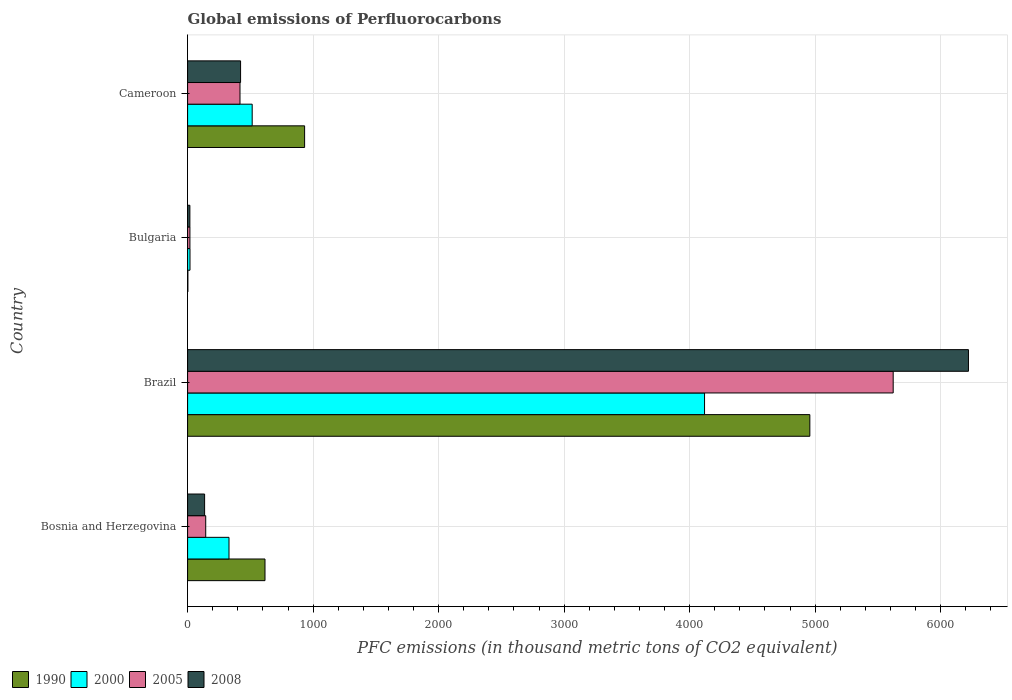Are the number of bars per tick equal to the number of legend labels?
Your answer should be very brief. Yes. How many bars are there on the 2nd tick from the bottom?
Offer a terse response. 4. What is the label of the 4th group of bars from the top?
Give a very brief answer. Bosnia and Herzegovina. What is the global emissions of Perfluorocarbons in 2005 in Bulgaria?
Your answer should be compact. 18.5. Across all countries, what is the maximum global emissions of Perfluorocarbons in 2008?
Give a very brief answer. 6221.8. Across all countries, what is the minimum global emissions of Perfluorocarbons in 1990?
Offer a very short reply. 2.2. In which country was the global emissions of Perfluorocarbons in 2008 maximum?
Make the answer very short. Brazil. In which country was the global emissions of Perfluorocarbons in 1990 minimum?
Ensure brevity in your answer.  Bulgaria. What is the total global emissions of Perfluorocarbons in 2008 in the graph?
Your answer should be compact. 6797.7. What is the difference between the global emissions of Perfluorocarbons in 1990 in Bosnia and Herzegovina and that in Cameroon?
Your response must be concise. -315.6. What is the difference between the global emissions of Perfluorocarbons in 1990 in Brazil and the global emissions of Perfluorocarbons in 2005 in Bosnia and Herzegovina?
Your answer should be compact. 4813.7. What is the average global emissions of Perfluorocarbons in 2005 per country?
Make the answer very short. 1550.62. What is the difference between the global emissions of Perfluorocarbons in 1990 and global emissions of Perfluorocarbons in 2008 in Bulgaria?
Ensure brevity in your answer.  -16. In how many countries, is the global emissions of Perfluorocarbons in 1990 greater than 3400 thousand metric tons?
Offer a very short reply. 1. What is the ratio of the global emissions of Perfluorocarbons in 1990 in Bulgaria to that in Cameroon?
Provide a succinct answer. 0. What is the difference between the highest and the second highest global emissions of Perfluorocarbons in 2008?
Provide a short and direct response. 5799.7. What is the difference between the highest and the lowest global emissions of Perfluorocarbons in 2000?
Offer a very short reply. 4100. Is it the case that in every country, the sum of the global emissions of Perfluorocarbons in 1990 and global emissions of Perfluorocarbons in 2000 is greater than the sum of global emissions of Perfluorocarbons in 2008 and global emissions of Perfluorocarbons in 2005?
Offer a very short reply. No. What does the 4th bar from the top in Bulgaria represents?
Your answer should be compact. 1990. What does the 4th bar from the bottom in Bulgaria represents?
Ensure brevity in your answer.  2008. Is it the case that in every country, the sum of the global emissions of Perfluorocarbons in 2005 and global emissions of Perfluorocarbons in 2008 is greater than the global emissions of Perfluorocarbons in 2000?
Offer a very short reply. No. How many bars are there?
Provide a succinct answer. 16. Are all the bars in the graph horizontal?
Make the answer very short. Yes. How many countries are there in the graph?
Make the answer very short. 4. What is the difference between two consecutive major ticks on the X-axis?
Provide a succinct answer. 1000. Does the graph contain any zero values?
Your response must be concise. No. What is the title of the graph?
Keep it short and to the point. Global emissions of Perfluorocarbons. What is the label or title of the X-axis?
Give a very brief answer. PFC emissions (in thousand metric tons of CO2 equivalent). What is the label or title of the Y-axis?
Provide a short and direct response. Country. What is the PFC emissions (in thousand metric tons of CO2 equivalent) of 1990 in Bosnia and Herzegovina?
Offer a terse response. 616.7. What is the PFC emissions (in thousand metric tons of CO2 equivalent) in 2000 in Bosnia and Herzegovina?
Your answer should be very brief. 329.9. What is the PFC emissions (in thousand metric tons of CO2 equivalent) in 2005 in Bosnia and Herzegovina?
Your answer should be compact. 144.4. What is the PFC emissions (in thousand metric tons of CO2 equivalent) of 2008 in Bosnia and Herzegovina?
Offer a terse response. 135.6. What is the PFC emissions (in thousand metric tons of CO2 equivalent) of 1990 in Brazil?
Your response must be concise. 4958.1. What is the PFC emissions (in thousand metric tons of CO2 equivalent) in 2000 in Brazil?
Keep it short and to the point. 4119.1. What is the PFC emissions (in thousand metric tons of CO2 equivalent) in 2005 in Brazil?
Ensure brevity in your answer.  5622.1. What is the PFC emissions (in thousand metric tons of CO2 equivalent) of 2008 in Brazil?
Make the answer very short. 6221.8. What is the PFC emissions (in thousand metric tons of CO2 equivalent) in 2000 in Bulgaria?
Keep it short and to the point. 19.1. What is the PFC emissions (in thousand metric tons of CO2 equivalent) in 2005 in Bulgaria?
Your answer should be compact. 18.5. What is the PFC emissions (in thousand metric tons of CO2 equivalent) in 2008 in Bulgaria?
Provide a succinct answer. 18.2. What is the PFC emissions (in thousand metric tons of CO2 equivalent) in 1990 in Cameroon?
Offer a terse response. 932.3. What is the PFC emissions (in thousand metric tons of CO2 equivalent) of 2000 in Cameroon?
Keep it short and to the point. 514.7. What is the PFC emissions (in thousand metric tons of CO2 equivalent) of 2005 in Cameroon?
Make the answer very short. 417.5. What is the PFC emissions (in thousand metric tons of CO2 equivalent) of 2008 in Cameroon?
Your answer should be very brief. 422.1. Across all countries, what is the maximum PFC emissions (in thousand metric tons of CO2 equivalent) in 1990?
Make the answer very short. 4958.1. Across all countries, what is the maximum PFC emissions (in thousand metric tons of CO2 equivalent) of 2000?
Ensure brevity in your answer.  4119.1. Across all countries, what is the maximum PFC emissions (in thousand metric tons of CO2 equivalent) in 2005?
Keep it short and to the point. 5622.1. Across all countries, what is the maximum PFC emissions (in thousand metric tons of CO2 equivalent) in 2008?
Your response must be concise. 6221.8. Across all countries, what is the minimum PFC emissions (in thousand metric tons of CO2 equivalent) of 1990?
Keep it short and to the point. 2.2. Across all countries, what is the minimum PFC emissions (in thousand metric tons of CO2 equivalent) of 2005?
Provide a succinct answer. 18.5. Across all countries, what is the minimum PFC emissions (in thousand metric tons of CO2 equivalent) in 2008?
Ensure brevity in your answer.  18.2. What is the total PFC emissions (in thousand metric tons of CO2 equivalent) in 1990 in the graph?
Keep it short and to the point. 6509.3. What is the total PFC emissions (in thousand metric tons of CO2 equivalent) in 2000 in the graph?
Ensure brevity in your answer.  4982.8. What is the total PFC emissions (in thousand metric tons of CO2 equivalent) of 2005 in the graph?
Ensure brevity in your answer.  6202.5. What is the total PFC emissions (in thousand metric tons of CO2 equivalent) of 2008 in the graph?
Your answer should be compact. 6797.7. What is the difference between the PFC emissions (in thousand metric tons of CO2 equivalent) in 1990 in Bosnia and Herzegovina and that in Brazil?
Keep it short and to the point. -4341.4. What is the difference between the PFC emissions (in thousand metric tons of CO2 equivalent) in 2000 in Bosnia and Herzegovina and that in Brazil?
Your answer should be compact. -3789.2. What is the difference between the PFC emissions (in thousand metric tons of CO2 equivalent) of 2005 in Bosnia and Herzegovina and that in Brazil?
Provide a short and direct response. -5477.7. What is the difference between the PFC emissions (in thousand metric tons of CO2 equivalent) in 2008 in Bosnia and Herzegovina and that in Brazil?
Your answer should be compact. -6086.2. What is the difference between the PFC emissions (in thousand metric tons of CO2 equivalent) of 1990 in Bosnia and Herzegovina and that in Bulgaria?
Your answer should be very brief. 614.5. What is the difference between the PFC emissions (in thousand metric tons of CO2 equivalent) of 2000 in Bosnia and Herzegovina and that in Bulgaria?
Keep it short and to the point. 310.8. What is the difference between the PFC emissions (in thousand metric tons of CO2 equivalent) in 2005 in Bosnia and Herzegovina and that in Bulgaria?
Offer a very short reply. 125.9. What is the difference between the PFC emissions (in thousand metric tons of CO2 equivalent) of 2008 in Bosnia and Herzegovina and that in Bulgaria?
Offer a very short reply. 117.4. What is the difference between the PFC emissions (in thousand metric tons of CO2 equivalent) of 1990 in Bosnia and Herzegovina and that in Cameroon?
Make the answer very short. -315.6. What is the difference between the PFC emissions (in thousand metric tons of CO2 equivalent) in 2000 in Bosnia and Herzegovina and that in Cameroon?
Make the answer very short. -184.8. What is the difference between the PFC emissions (in thousand metric tons of CO2 equivalent) of 2005 in Bosnia and Herzegovina and that in Cameroon?
Your answer should be compact. -273.1. What is the difference between the PFC emissions (in thousand metric tons of CO2 equivalent) of 2008 in Bosnia and Herzegovina and that in Cameroon?
Offer a very short reply. -286.5. What is the difference between the PFC emissions (in thousand metric tons of CO2 equivalent) in 1990 in Brazil and that in Bulgaria?
Your answer should be compact. 4955.9. What is the difference between the PFC emissions (in thousand metric tons of CO2 equivalent) in 2000 in Brazil and that in Bulgaria?
Your response must be concise. 4100. What is the difference between the PFC emissions (in thousand metric tons of CO2 equivalent) of 2005 in Brazil and that in Bulgaria?
Ensure brevity in your answer.  5603.6. What is the difference between the PFC emissions (in thousand metric tons of CO2 equivalent) of 2008 in Brazil and that in Bulgaria?
Ensure brevity in your answer.  6203.6. What is the difference between the PFC emissions (in thousand metric tons of CO2 equivalent) in 1990 in Brazil and that in Cameroon?
Your response must be concise. 4025.8. What is the difference between the PFC emissions (in thousand metric tons of CO2 equivalent) in 2000 in Brazil and that in Cameroon?
Give a very brief answer. 3604.4. What is the difference between the PFC emissions (in thousand metric tons of CO2 equivalent) of 2005 in Brazil and that in Cameroon?
Make the answer very short. 5204.6. What is the difference between the PFC emissions (in thousand metric tons of CO2 equivalent) in 2008 in Brazil and that in Cameroon?
Your answer should be compact. 5799.7. What is the difference between the PFC emissions (in thousand metric tons of CO2 equivalent) in 1990 in Bulgaria and that in Cameroon?
Make the answer very short. -930.1. What is the difference between the PFC emissions (in thousand metric tons of CO2 equivalent) of 2000 in Bulgaria and that in Cameroon?
Give a very brief answer. -495.6. What is the difference between the PFC emissions (in thousand metric tons of CO2 equivalent) of 2005 in Bulgaria and that in Cameroon?
Provide a succinct answer. -399. What is the difference between the PFC emissions (in thousand metric tons of CO2 equivalent) in 2008 in Bulgaria and that in Cameroon?
Give a very brief answer. -403.9. What is the difference between the PFC emissions (in thousand metric tons of CO2 equivalent) in 1990 in Bosnia and Herzegovina and the PFC emissions (in thousand metric tons of CO2 equivalent) in 2000 in Brazil?
Provide a succinct answer. -3502.4. What is the difference between the PFC emissions (in thousand metric tons of CO2 equivalent) of 1990 in Bosnia and Herzegovina and the PFC emissions (in thousand metric tons of CO2 equivalent) of 2005 in Brazil?
Make the answer very short. -5005.4. What is the difference between the PFC emissions (in thousand metric tons of CO2 equivalent) of 1990 in Bosnia and Herzegovina and the PFC emissions (in thousand metric tons of CO2 equivalent) of 2008 in Brazil?
Keep it short and to the point. -5605.1. What is the difference between the PFC emissions (in thousand metric tons of CO2 equivalent) in 2000 in Bosnia and Herzegovina and the PFC emissions (in thousand metric tons of CO2 equivalent) in 2005 in Brazil?
Your answer should be very brief. -5292.2. What is the difference between the PFC emissions (in thousand metric tons of CO2 equivalent) of 2000 in Bosnia and Herzegovina and the PFC emissions (in thousand metric tons of CO2 equivalent) of 2008 in Brazil?
Make the answer very short. -5891.9. What is the difference between the PFC emissions (in thousand metric tons of CO2 equivalent) in 2005 in Bosnia and Herzegovina and the PFC emissions (in thousand metric tons of CO2 equivalent) in 2008 in Brazil?
Your answer should be compact. -6077.4. What is the difference between the PFC emissions (in thousand metric tons of CO2 equivalent) in 1990 in Bosnia and Herzegovina and the PFC emissions (in thousand metric tons of CO2 equivalent) in 2000 in Bulgaria?
Offer a very short reply. 597.6. What is the difference between the PFC emissions (in thousand metric tons of CO2 equivalent) of 1990 in Bosnia and Herzegovina and the PFC emissions (in thousand metric tons of CO2 equivalent) of 2005 in Bulgaria?
Offer a very short reply. 598.2. What is the difference between the PFC emissions (in thousand metric tons of CO2 equivalent) of 1990 in Bosnia and Herzegovina and the PFC emissions (in thousand metric tons of CO2 equivalent) of 2008 in Bulgaria?
Your answer should be compact. 598.5. What is the difference between the PFC emissions (in thousand metric tons of CO2 equivalent) of 2000 in Bosnia and Herzegovina and the PFC emissions (in thousand metric tons of CO2 equivalent) of 2005 in Bulgaria?
Provide a short and direct response. 311.4. What is the difference between the PFC emissions (in thousand metric tons of CO2 equivalent) of 2000 in Bosnia and Herzegovina and the PFC emissions (in thousand metric tons of CO2 equivalent) of 2008 in Bulgaria?
Offer a very short reply. 311.7. What is the difference between the PFC emissions (in thousand metric tons of CO2 equivalent) of 2005 in Bosnia and Herzegovina and the PFC emissions (in thousand metric tons of CO2 equivalent) of 2008 in Bulgaria?
Your answer should be very brief. 126.2. What is the difference between the PFC emissions (in thousand metric tons of CO2 equivalent) in 1990 in Bosnia and Herzegovina and the PFC emissions (in thousand metric tons of CO2 equivalent) in 2000 in Cameroon?
Keep it short and to the point. 102. What is the difference between the PFC emissions (in thousand metric tons of CO2 equivalent) of 1990 in Bosnia and Herzegovina and the PFC emissions (in thousand metric tons of CO2 equivalent) of 2005 in Cameroon?
Provide a succinct answer. 199.2. What is the difference between the PFC emissions (in thousand metric tons of CO2 equivalent) in 1990 in Bosnia and Herzegovina and the PFC emissions (in thousand metric tons of CO2 equivalent) in 2008 in Cameroon?
Give a very brief answer. 194.6. What is the difference between the PFC emissions (in thousand metric tons of CO2 equivalent) of 2000 in Bosnia and Herzegovina and the PFC emissions (in thousand metric tons of CO2 equivalent) of 2005 in Cameroon?
Keep it short and to the point. -87.6. What is the difference between the PFC emissions (in thousand metric tons of CO2 equivalent) of 2000 in Bosnia and Herzegovina and the PFC emissions (in thousand metric tons of CO2 equivalent) of 2008 in Cameroon?
Provide a succinct answer. -92.2. What is the difference between the PFC emissions (in thousand metric tons of CO2 equivalent) of 2005 in Bosnia and Herzegovina and the PFC emissions (in thousand metric tons of CO2 equivalent) of 2008 in Cameroon?
Your response must be concise. -277.7. What is the difference between the PFC emissions (in thousand metric tons of CO2 equivalent) in 1990 in Brazil and the PFC emissions (in thousand metric tons of CO2 equivalent) in 2000 in Bulgaria?
Keep it short and to the point. 4939. What is the difference between the PFC emissions (in thousand metric tons of CO2 equivalent) in 1990 in Brazil and the PFC emissions (in thousand metric tons of CO2 equivalent) in 2005 in Bulgaria?
Your response must be concise. 4939.6. What is the difference between the PFC emissions (in thousand metric tons of CO2 equivalent) of 1990 in Brazil and the PFC emissions (in thousand metric tons of CO2 equivalent) of 2008 in Bulgaria?
Your response must be concise. 4939.9. What is the difference between the PFC emissions (in thousand metric tons of CO2 equivalent) in 2000 in Brazil and the PFC emissions (in thousand metric tons of CO2 equivalent) in 2005 in Bulgaria?
Provide a succinct answer. 4100.6. What is the difference between the PFC emissions (in thousand metric tons of CO2 equivalent) of 2000 in Brazil and the PFC emissions (in thousand metric tons of CO2 equivalent) of 2008 in Bulgaria?
Provide a succinct answer. 4100.9. What is the difference between the PFC emissions (in thousand metric tons of CO2 equivalent) in 2005 in Brazil and the PFC emissions (in thousand metric tons of CO2 equivalent) in 2008 in Bulgaria?
Give a very brief answer. 5603.9. What is the difference between the PFC emissions (in thousand metric tons of CO2 equivalent) in 1990 in Brazil and the PFC emissions (in thousand metric tons of CO2 equivalent) in 2000 in Cameroon?
Provide a short and direct response. 4443.4. What is the difference between the PFC emissions (in thousand metric tons of CO2 equivalent) of 1990 in Brazil and the PFC emissions (in thousand metric tons of CO2 equivalent) of 2005 in Cameroon?
Keep it short and to the point. 4540.6. What is the difference between the PFC emissions (in thousand metric tons of CO2 equivalent) of 1990 in Brazil and the PFC emissions (in thousand metric tons of CO2 equivalent) of 2008 in Cameroon?
Offer a terse response. 4536. What is the difference between the PFC emissions (in thousand metric tons of CO2 equivalent) in 2000 in Brazil and the PFC emissions (in thousand metric tons of CO2 equivalent) in 2005 in Cameroon?
Your response must be concise. 3701.6. What is the difference between the PFC emissions (in thousand metric tons of CO2 equivalent) in 2000 in Brazil and the PFC emissions (in thousand metric tons of CO2 equivalent) in 2008 in Cameroon?
Offer a very short reply. 3697. What is the difference between the PFC emissions (in thousand metric tons of CO2 equivalent) of 2005 in Brazil and the PFC emissions (in thousand metric tons of CO2 equivalent) of 2008 in Cameroon?
Your response must be concise. 5200. What is the difference between the PFC emissions (in thousand metric tons of CO2 equivalent) of 1990 in Bulgaria and the PFC emissions (in thousand metric tons of CO2 equivalent) of 2000 in Cameroon?
Provide a short and direct response. -512.5. What is the difference between the PFC emissions (in thousand metric tons of CO2 equivalent) of 1990 in Bulgaria and the PFC emissions (in thousand metric tons of CO2 equivalent) of 2005 in Cameroon?
Provide a succinct answer. -415.3. What is the difference between the PFC emissions (in thousand metric tons of CO2 equivalent) of 1990 in Bulgaria and the PFC emissions (in thousand metric tons of CO2 equivalent) of 2008 in Cameroon?
Provide a short and direct response. -419.9. What is the difference between the PFC emissions (in thousand metric tons of CO2 equivalent) in 2000 in Bulgaria and the PFC emissions (in thousand metric tons of CO2 equivalent) in 2005 in Cameroon?
Offer a terse response. -398.4. What is the difference between the PFC emissions (in thousand metric tons of CO2 equivalent) in 2000 in Bulgaria and the PFC emissions (in thousand metric tons of CO2 equivalent) in 2008 in Cameroon?
Ensure brevity in your answer.  -403. What is the difference between the PFC emissions (in thousand metric tons of CO2 equivalent) in 2005 in Bulgaria and the PFC emissions (in thousand metric tons of CO2 equivalent) in 2008 in Cameroon?
Provide a succinct answer. -403.6. What is the average PFC emissions (in thousand metric tons of CO2 equivalent) of 1990 per country?
Offer a terse response. 1627.33. What is the average PFC emissions (in thousand metric tons of CO2 equivalent) in 2000 per country?
Keep it short and to the point. 1245.7. What is the average PFC emissions (in thousand metric tons of CO2 equivalent) in 2005 per country?
Offer a very short reply. 1550.62. What is the average PFC emissions (in thousand metric tons of CO2 equivalent) in 2008 per country?
Your answer should be compact. 1699.42. What is the difference between the PFC emissions (in thousand metric tons of CO2 equivalent) in 1990 and PFC emissions (in thousand metric tons of CO2 equivalent) in 2000 in Bosnia and Herzegovina?
Your answer should be very brief. 286.8. What is the difference between the PFC emissions (in thousand metric tons of CO2 equivalent) in 1990 and PFC emissions (in thousand metric tons of CO2 equivalent) in 2005 in Bosnia and Herzegovina?
Your answer should be compact. 472.3. What is the difference between the PFC emissions (in thousand metric tons of CO2 equivalent) of 1990 and PFC emissions (in thousand metric tons of CO2 equivalent) of 2008 in Bosnia and Herzegovina?
Your answer should be compact. 481.1. What is the difference between the PFC emissions (in thousand metric tons of CO2 equivalent) of 2000 and PFC emissions (in thousand metric tons of CO2 equivalent) of 2005 in Bosnia and Herzegovina?
Ensure brevity in your answer.  185.5. What is the difference between the PFC emissions (in thousand metric tons of CO2 equivalent) of 2000 and PFC emissions (in thousand metric tons of CO2 equivalent) of 2008 in Bosnia and Herzegovina?
Offer a terse response. 194.3. What is the difference between the PFC emissions (in thousand metric tons of CO2 equivalent) of 2005 and PFC emissions (in thousand metric tons of CO2 equivalent) of 2008 in Bosnia and Herzegovina?
Your answer should be compact. 8.8. What is the difference between the PFC emissions (in thousand metric tons of CO2 equivalent) in 1990 and PFC emissions (in thousand metric tons of CO2 equivalent) in 2000 in Brazil?
Give a very brief answer. 839. What is the difference between the PFC emissions (in thousand metric tons of CO2 equivalent) in 1990 and PFC emissions (in thousand metric tons of CO2 equivalent) in 2005 in Brazil?
Your response must be concise. -664. What is the difference between the PFC emissions (in thousand metric tons of CO2 equivalent) in 1990 and PFC emissions (in thousand metric tons of CO2 equivalent) in 2008 in Brazil?
Offer a very short reply. -1263.7. What is the difference between the PFC emissions (in thousand metric tons of CO2 equivalent) in 2000 and PFC emissions (in thousand metric tons of CO2 equivalent) in 2005 in Brazil?
Your response must be concise. -1503. What is the difference between the PFC emissions (in thousand metric tons of CO2 equivalent) in 2000 and PFC emissions (in thousand metric tons of CO2 equivalent) in 2008 in Brazil?
Keep it short and to the point. -2102.7. What is the difference between the PFC emissions (in thousand metric tons of CO2 equivalent) of 2005 and PFC emissions (in thousand metric tons of CO2 equivalent) of 2008 in Brazil?
Provide a short and direct response. -599.7. What is the difference between the PFC emissions (in thousand metric tons of CO2 equivalent) of 1990 and PFC emissions (in thousand metric tons of CO2 equivalent) of 2000 in Bulgaria?
Provide a short and direct response. -16.9. What is the difference between the PFC emissions (in thousand metric tons of CO2 equivalent) in 1990 and PFC emissions (in thousand metric tons of CO2 equivalent) in 2005 in Bulgaria?
Your answer should be compact. -16.3. What is the difference between the PFC emissions (in thousand metric tons of CO2 equivalent) of 1990 and PFC emissions (in thousand metric tons of CO2 equivalent) of 2008 in Bulgaria?
Offer a very short reply. -16. What is the difference between the PFC emissions (in thousand metric tons of CO2 equivalent) in 2005 and PFC emissions (in thousand metric tons of CO2 equivalent) in 2008 in Bulgaria?
Provide a short and direct response. 0.3. What is the difference between the PFC emissions (in thousand metric tons of CO2 equivalent) of 1990 and PFC emissions (in thousand metric tons of CO2 equivalent) of 2000 in Cameroon?
Provide a short and direct response. 417.6. What is the difference between the PFC emissions (in thousand metric tons of CO2 equivalent) of 1990 and PFC emissions (in thousand metric tons of CO2 equivalent) of 2005 in Cameroon?
Provide a short and direct response. 514.8. What is the difference between the PFC emissions (in thousand metric tons of CO2 equivalent) of 1990 and PFC emissions (in thousand metric tons of CO2 equivalent) of 2008 in Cameroon?
Provide a succinct answer. 510.2. What is the difference between the PFC emissions (in thousand metric tons of CO2 equivalent) in 2000 and PFC emissions (in thousand metric tons of CO2 equivalent) in 2005 in Cameroon?
Provide a short and direct response. 97.2. What is the difference between the PFC emissions (in thousand metric tons of CO2 equivalent) in 2000 and PFC emissions (in thousand metric tons of CO2 equivalent) in 2008 in Cameroon?
Your answer should be very brief. 92.6. What is the difference between the PFC emissions (in thousand metric tons of CO2 equivalent) in 2005 and PFC emissions (in thousand metric tons of CO2 equivalent) in 2008 in Cameroon?
Offer a very short reply. -4.6. What is the ratio of the PFC emissions (in thousand metric tons of CO2 equivalent) in 1990 in Bosnia and Herzegovina to that in Brazil?
Your answer should be very brief. 0.12. What is the ratio of the PFC emissions (in thousand metric tons of CO2 equivalent) in 2000 in Bosnia and Herzegovina to that in Brazil?
Provide a succinct answer. 0.08. What is the ratio of the PFC emissions (in thousand metric tons of CO2 equivalent) of 2005 in Bosnia and Herzegovina to that in Brazil?
Provide a succinct answer. 0.03. What is the ratio of the PFC emissions (in thousand metric tons of CO2 equivalent) in 2008 in Bosnia and Herzegovina to that in Brazil?
Your response must be concise. 0.02. What is the ratio of the PFC emissions (in thousand metric tons of CO2 equivalent) of 1990 in Bosnia and Herzegovina to that in Bulgaria?
Give a very brief answer. 280.32. What is the ratio of the PFC emissions (in thousand metric tons of CO2 equivalent) of 2000 in Bosnia and Herzegovina to that in Bulgaria?
Make the answer very short. 17.27. What is the ratio of the PFC emissions (in thousand metric tons of CO2 equivalent) of 2005 in Bosnia and Herzegovina to that in Bulgaria?
Ensure brevity in your answer.  7.81. What is the ratio of the PFC emissions (in thousand metric tons of CO2 equivalent) of 2008 in Bosnia and Herzegovina to that in Bulgaria?
Provide a succinct answer. 7.45. What is the ratio of the PFC emissions (in thousand metric tons of CO2 equivalent) in 1990 in Bosnia and Herzegovina to that in Cameroon?
Make the answer very short. 0.66. What is the ratio of the PFC emissions (in thousand metric tons of CO2 equivalent) of 2000 in Bosnia and Herzegovina to that in Cameroon?
Your response must be concise. 0.64. What is the ratio of the PFC emissions (in thousand metric tons of CO2 equivalent) in 2005 in Bosnia and Herzegovina to that in Cameroon?
Your answer should be very brief. 0.35. What is the ratio of the PFC emissions (in thousand metric tons of CO2 equivalent) of 2008 in Bosnia and Herzegovina to that in Cameroon?
Your answer should be very brief. 0.32. What is the ratio of the PFC emissions (in thousand metric tons of CO2 equivalent) of 1990 in Brazil to that in Bulgaria?
Ensure brevity in your answer.  2253.68. What is the ratio of the PFC emissions (in thousand metric tons of CO2 equivalent) in 2000 in Brazil to that in Bulgaria?
Your answer should be very brief. 215.66. What is the ratio of the PFC emissions (in thousand metric tons of CO2 equivalent) of 2005 in Brazil to that in Bulgaria?
Give a very brief answer. 303.9. What is the ratio of the PFC emissions (in thousand metric tons of CO2 equivalent) in 2008 in Brazil to that in Bulgaria?
Provide a short and direct response. 341.86. What is the ratio of the PFC emissions (in thousand metric tons of CO2 equivalent) in 1990 in Brazil to that in Cameroon?
Keep it short and to the point. 5.32. What is the ratio of the PFC emissions (in thousand metric tons of CO2 equivalent) in 2000 in Brazil to that in Cameroon?
Your answer should be compact. 8. What is the ratio of the PFC emissions (in thousand metric tons of CO2 equivalent) in 2005 in Brazil to that in Cameroon?
Offer a very short reply. 13.47. What is the ratio of the PFC emissions (in thousand metric tons of CO2 equivalent) in 2008 in Brazil to that in Cameroon?
Provide a succinct answer. 14.74. What is the ratio of the PFC emissions (in thousand metric tons of CO2 equivalent) of 1990 in Bulgaria to that in Cameroon?
Offer a very short reply. 0. What is the ratio of the PFC emissions (in thousand metric tons of CO2 equivalent) of 2000 in Bulgaria to that in Cameroon?
Offer a terse response. 0.04. What is the ratio of the PFC emissions (in thousand metric tons of CO2 equivalent) in 2005 in Bulgaria to that in Cameroon?
Your answer should be compact. 0.04. What is the ratio of the PFC emissions (in thousand metric tons of CO2 equivalent) in 2008 in Bulgaria to that in Cameroon?
Provide a short and direct response. 0.04. What is the difference between the highest and the second highest PFC emissions (in thousand metric tons of CO2 equivalent) in 1990?
Make the answer very short. 4025.8. What is the difference between the highest and the second highest PFC emissions (in thousand metric tons of CO2 equivalent) in 2000?
Make the answer very short. 3604.4. What is the difference between the highest and the second highest PFC emissions (in thousand metric tons of CO2 equivalent) in 2005?
Ensure brevity in your answer.  5204.6. What is the difference between the highest and the second highest PFC emissions (in thousand metric tons of CO2 equivalent) in 2008?
Keep it short and to the point. 5799.7. What is the difference between the highest and the lowest PFC emissions (in thousand metric tons of CO2 equivalent) in 1990?
Your answer should be very brief. 4955.9. What is the difference between the highest and the lowest PFC emissions (in thousand metric tons of CO2 equivalent) of 2000?
Your response must be concise. 4100. What is the difference between the highest and the lowest PFC emissions (in thousand metric tons of CO2 equivalent) in 2005?
Offer a very short reply. 5603.6. What is the difference between the highest and the lowest PFC emissions (in thousand metric tons of CO2 equivalent) of 2008?
Give a very brief answer. 6203.6. 